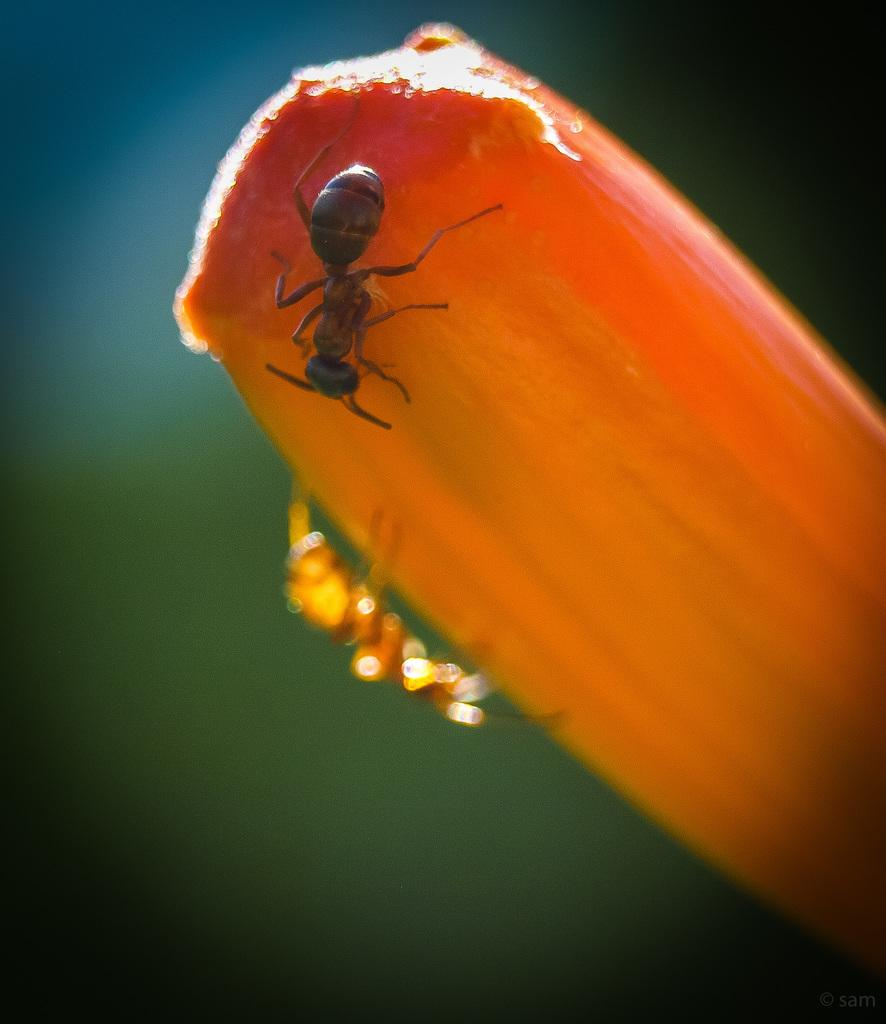What is the main subject of the picture? The main subject of the picture is an ice cream. What color is the ice cream? The ice cream is orange in color. Are there any other creatures or objects on the ice cream? Yes, there are two ants on the ice cream. What can be seen in the background of the image? The background of the image is green, and it is blurred. What type of work are the ants doing on the ice cream? The ants are not depicted as doing any work on the ice cream; they are simply present on it. What scent can be detected from the ice cream in the image? The image is not accompanied by any scent, so it is not possible to determine the scent of the ice cream from the image. 